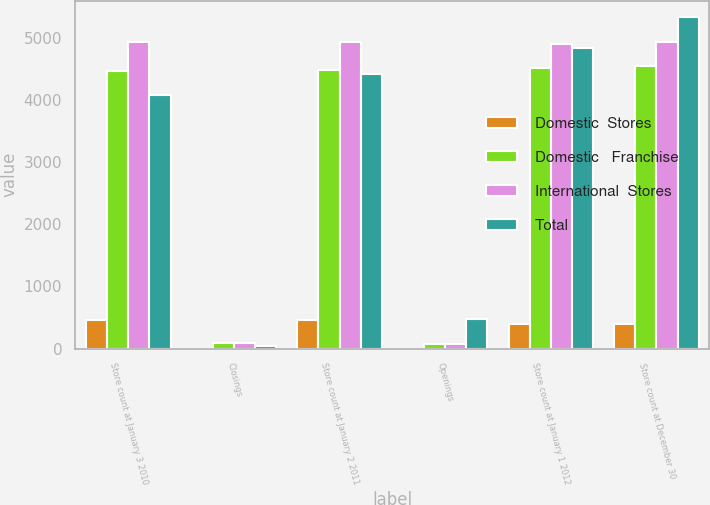<chart> <loc_0><loc_0><loc_500><loc_500><stacked_bar_chart><ecel><fcel>Store count at January 3 2010<fcel>Closings<fcel>Store count at January 2 2011<fcel>Openings<fcel>Store count at January 1 2012<fcel>Store count at December 30<nl><fcel>Domestic  Stores<fcel>466<fcel>1<fcel>454<fcel>1<fcel>394<fcel>388<nl><fcel>Domestic   Franchise<fcel>4461<fcel>85<fcel>4475<fcel>66<fcel>4513<fcel>4540<nl><fcel>International  Stores<fcel>4927<fcel>86<fcel>4929<fcel>67<fcel>4907<fcel>4928<nl><fcel>Total<fcel>4072<fcel>42<fcel>4422<fcel>473<fcel>4835<fcel>5327<nl></chart> 